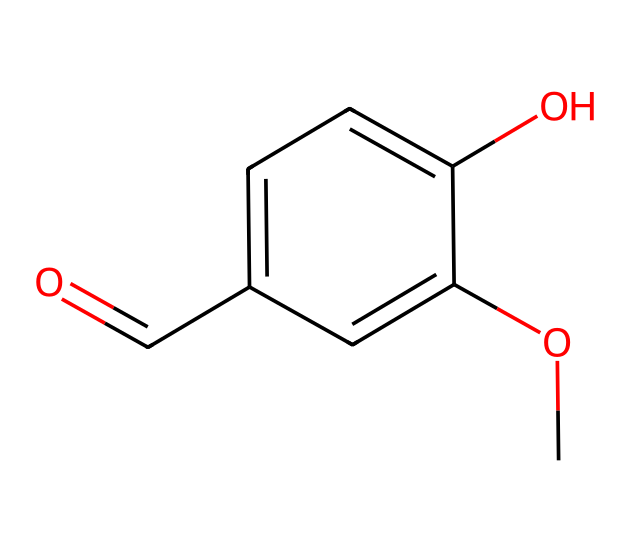What is the molecular formula of vanillin? The molecular formula can be derived by counting the number of each type of atom in the SMILES representation. It contains 8 carbon (C) atoms, 8 hydrogen (H) atoms, and 3 oxygen (O) atoms. Therefore, the molecular formula is C8H8O3.
Answer: C8H8O3 How many rings are present in the structure of vanillin? In the given SMILES representation, the 'c' denotes aromatic carbon atoms, and there are no additional notations that indicate multiple cycles. This indicates that there is a single aromatic ring present in the chemical structure.
Answer: 1 What type of functional group is present in vanillin? Based on its structure indicated in the SMILES, vanillin contains both an aldehyde group (indicated by the 'O=' at the beginning) and a hydroxyl group (indicated by 'O' attached to an aromatic ring). Therefore, it is classified as having both an aldehyde and a hydroxyl functional group.
Answer: aldehyde, hydroxyl How many oxygen atoms are present in the vanillin structure? Reviewing the SMILES representation, we can see two distinct oxygen atoms within functional groups (the aldehyde and hydroxyl) and another ether-like oxygen from the methoxy group. Therefore, there are three oxygen atoms present in total.
Answer: 3 What makes vanillin a high-value flavoring compound? The distinct pleasant aroma and flavoring properties of vanillin stem from its specific chemical structure, which contains multiple functional groups that contribute to its characteristic taste, especially in foods and perfumes. Additionally, it is widely used in the food industry, which elevates its commercial value.
Answer: aroma, flavoring properties What is the common source of vanillin? Vanillin is most commonly sourced from vanilla beans, which are the fruits of the vanilla orchid. However, it can also be synthesized chemically from guaiacol or lignin, but the natural extraction from vanilla beans is the traditional and most recognized source.
Answer: vanilla beans 